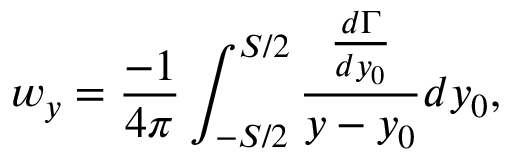Convert formula to latex. <formula><loc_0><loc_0><loc_500><loc_500>w _ { y } = \frac { - 1 } { 4 \pi } \int _ { - S / 2 } ^ { S / 2 } \frac { \frac { d \Gamma } { d y _ { 0 } } } { y - y _ { 0 } } { d y _ { 0 } } ,</formula> 